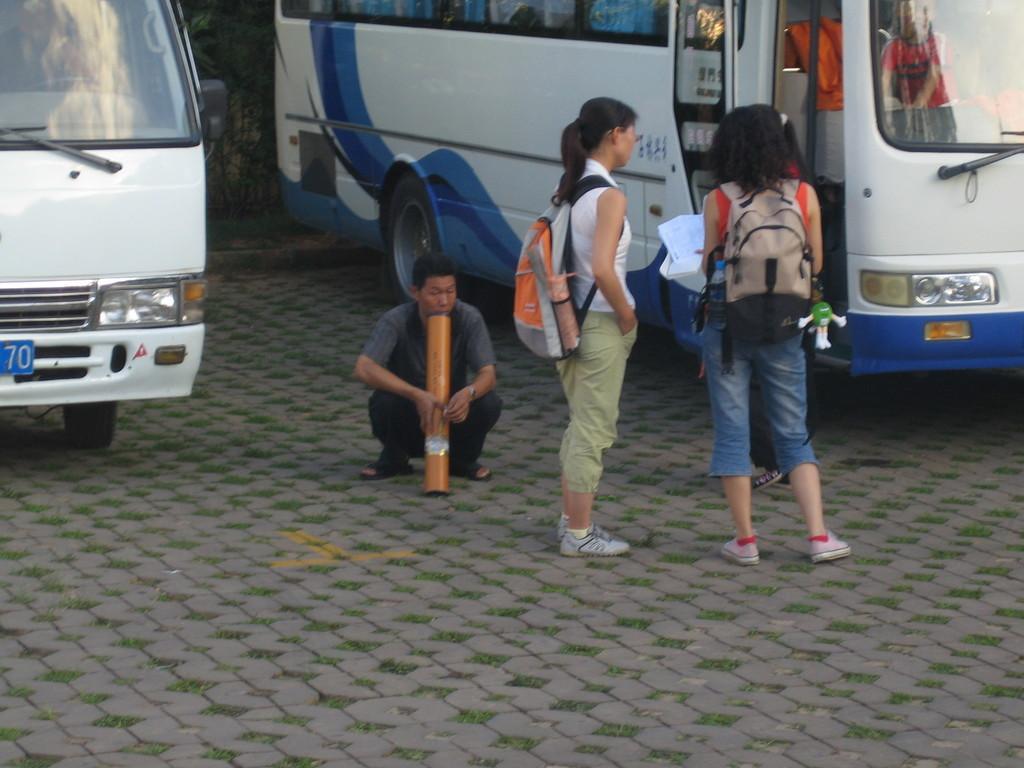Please provide a concise description of this image. In this picture there are people in the center of the image and there are buses and a tree in the background area of the image. 